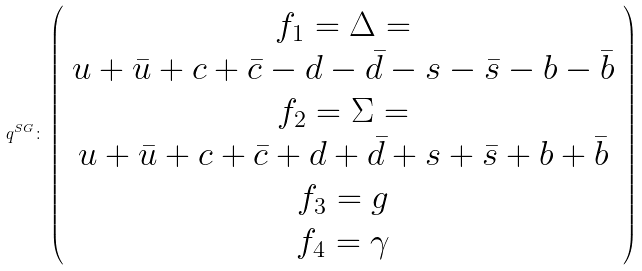Convert formula to latex. <formula><loc_0><loc_0><loc_500><loc_500>q ^ { S G } \colon \left ( \begin{array} { c } { { f } _ { 1 } } = \Delta = \\ u + \bar { u } + c + \bar { c } - d - \bar { d } - s - \bar { s } - b - \bar { b } \\ { { f } _ { 2 } } = \Sigma = \\ u + \bar { u } + c + \bar { c } + d + \bar { d } + s + \bar { s } + b + \bar { b } \\ { { f } _ { 3 } } = g \\ { { f } _ { 4 } } = \gamma \end{array} \right )</formula> 